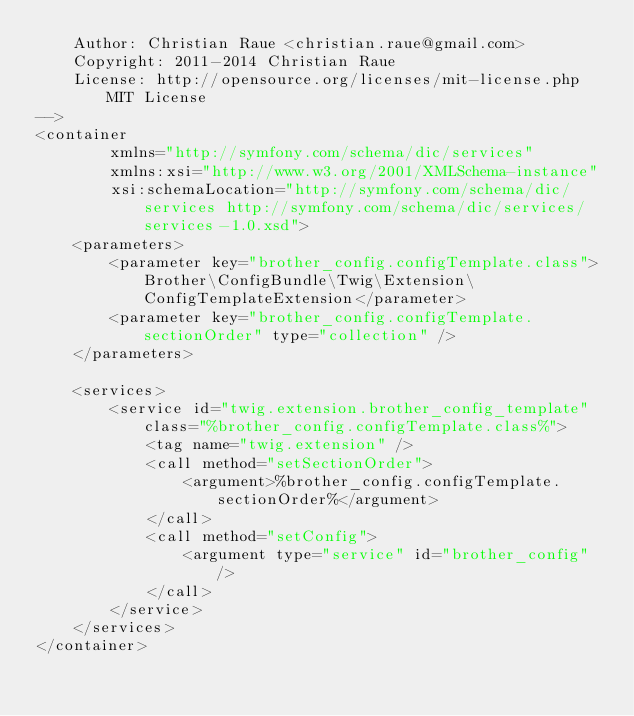Convert code to text. <code><loc_0><loc_0><loc_500><loc_500><_XML_>	Author: Christian Raue <christian.raue@gmail.com>
	Copyright: 2011-2014 Christian Raue
	License: http://opensource.org/licenses/mit-license.php MIT License
-->
<container
		xmlns="http://symfony.com/schema/dic/services"
		xmlns:xsi="http://www.w3.org/2001/XMLSchema-instance"
		xsi:schemaLocation="http://symfony.com/schema/dic/services http://symfony.com/schema/dic/services/services-1.0.xsd">
	<parameters>
		<parameter key="brother_config.configTemplate.class">Brother\ConfigBundle\Twig\Extension\ConfigTemplateExtension</parameter>
		<parameter key="brother_config.configTemplate.sectionOrder" type="collection" />
	</parameters>

	<services>
		<service id="twig.extension.brother_config_template" class="%brother_config.configTemplate.class%">
			<tag name="twig.extension" />
			<call method="setSectionOrder">
				<argument>%brother_config.configTemplate.sectionOrder%</argument>
			</call>
			<call method="setConfig">
				<argument type="service" id="brother_config" />
			</call>
		</service>
	</services>
</container>
</code> 